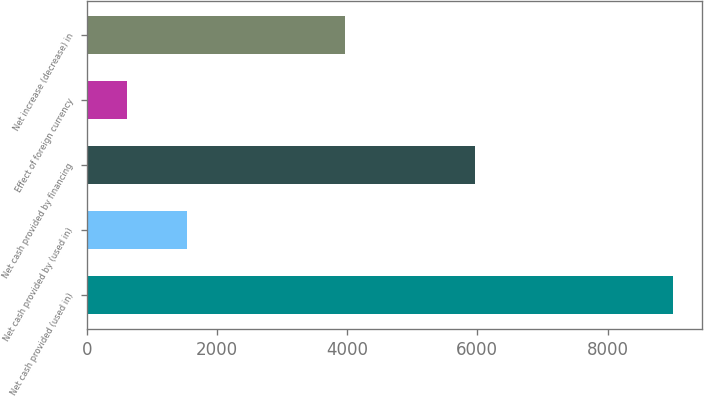Convert chart. <chart><loc_0><loc_0><loc_500><loc_500><bar_chart><fcel>Net cash provided (used in)<fcel>Net cash provided by (used in)<fcel>Net cash provided by financing<fcel>Effect of foreign currency<fcel>Net increase (decrease) in<nl><fcel>9008<fcel>1535<fcel>5963<fcel>613<fcel>3967<nl></chart> 